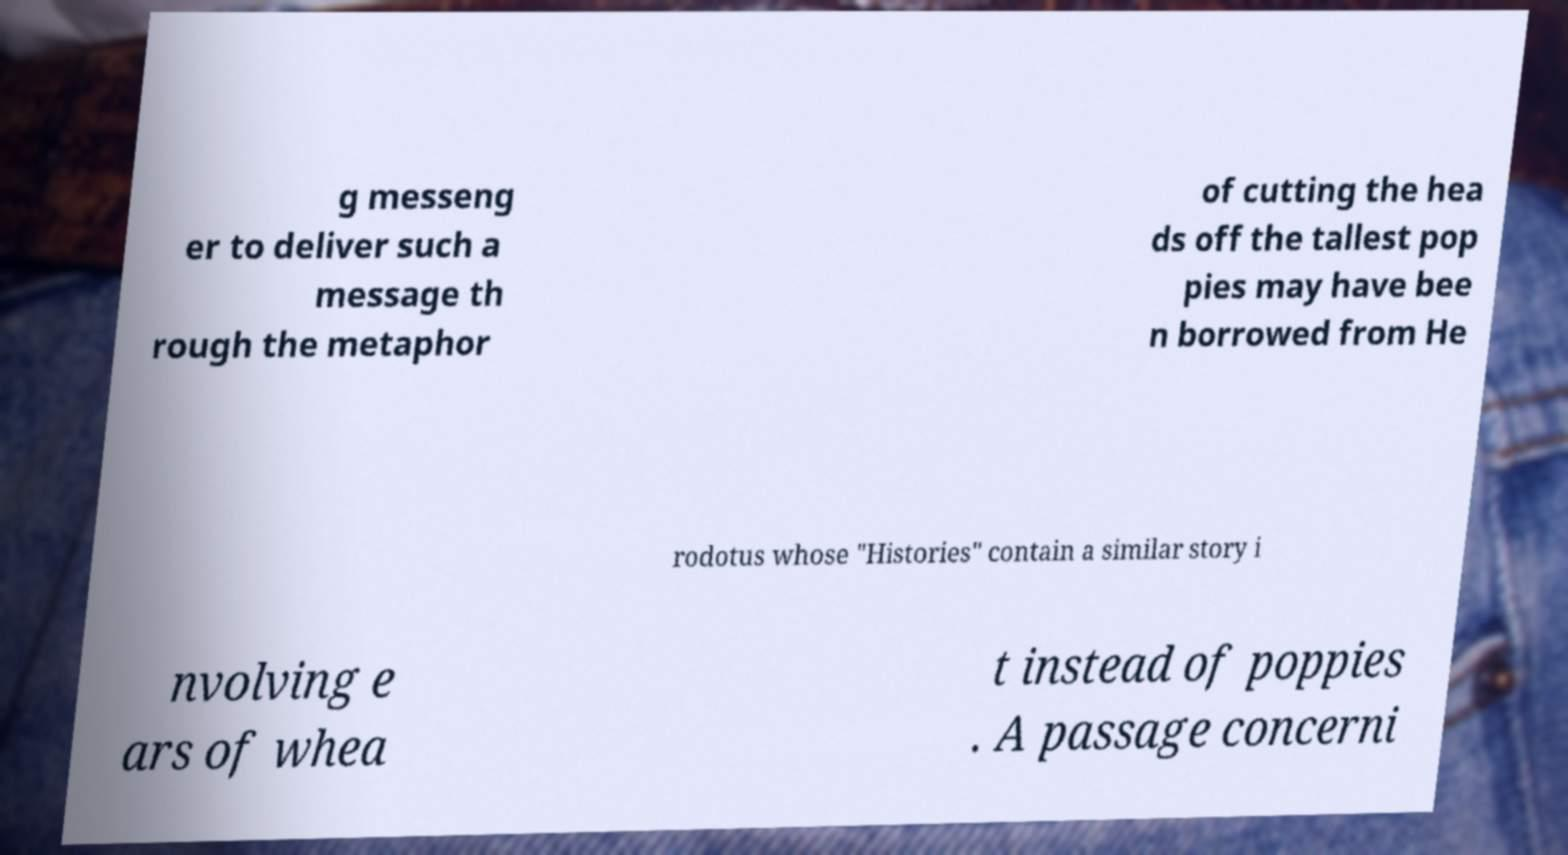Please read and relay the text visible in this image. What does it say? g messeng er to deliver such a message th rough the metaphor of cutting the hea ds off the tallest pop pies may have bee n borrowed from He rodotus whose "Histories" contain a similar story i nvolving e ars of whea t instead of poppies . A passage concerni 